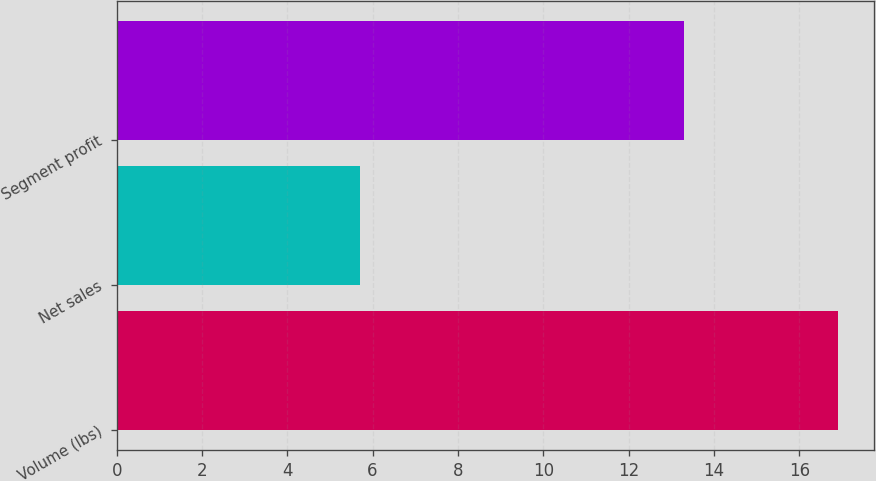Convert chart. <chart><loc_0><loc_0><loc_500><loc_500><bar_chart><fcel>Volume (lbs)<fcel>Net sales<fcel>Segment profit<nl><fcel>16.9<fcel>5.7<fcel>13.3<nl></chart> 